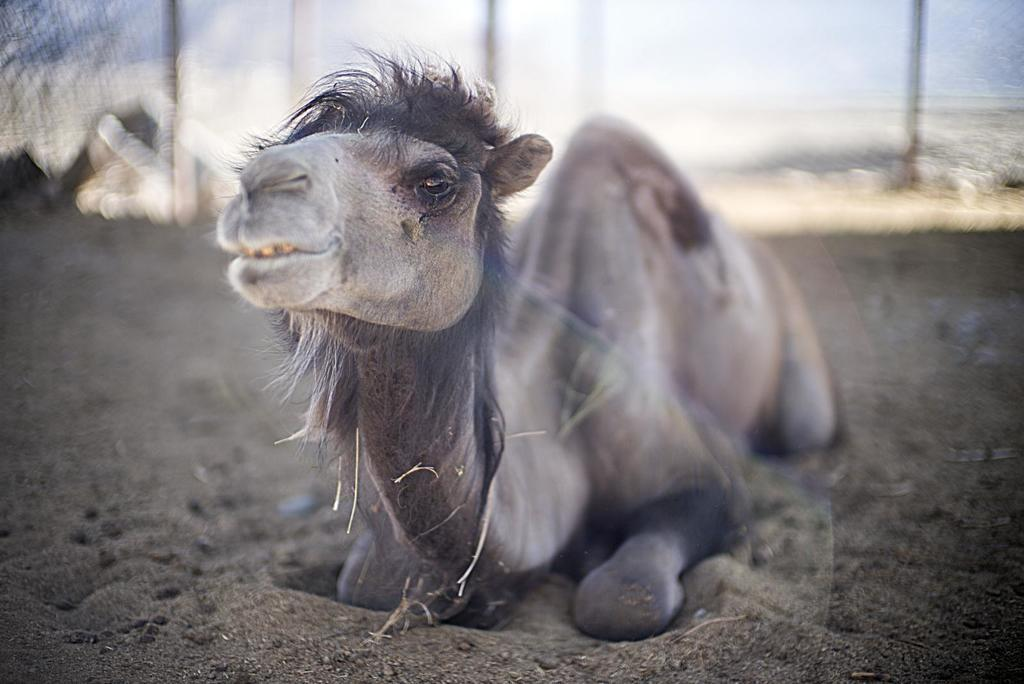What is the main subject in the foreground of the picture? There is a camel in the foreground of the picture. What type of terrain is visible in the foreground of the picture? There is sand in the foreground of the picture. How would you describe the background of the image? The background of the image is blurred. What type of vegetable is being crushed by the camel in the image? There is no vegetable present in the image, and the camel is not crushing anything. 